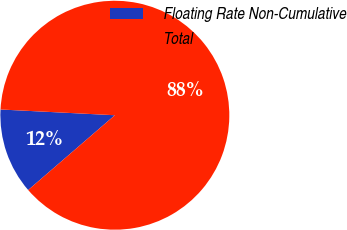Convert chart. <chart><loc_0><loc_0><loc_500><loc_500><pie_chart><fcel>Floating Rate Non-Cumulative<fcel>Total<nl><fcel>12.13%<fcel>87.87%<nl></chart> 